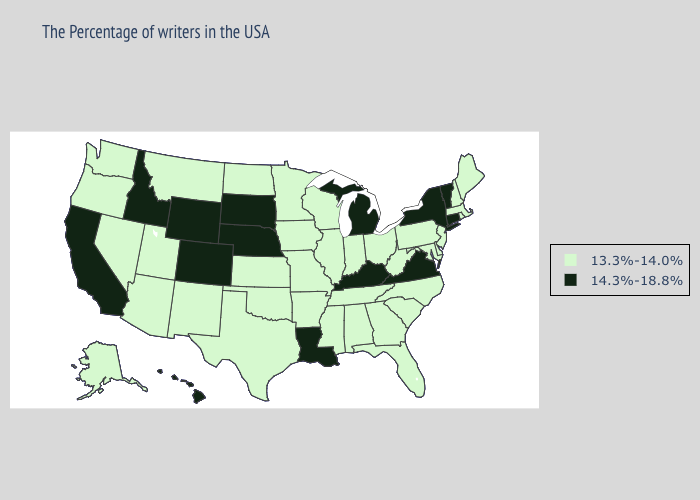Among the states that border Texas , which have the lowest value?
Quick response, please. Arkansas, Oklahoma, New Mexico. Name the states that have a value in the range 14.3%-18.8%?
Concise answer only. Vermont, Connecticut, New York, Virginia, Michigan, Kentucky, Louisiana, Nebraska, South Dakota, Wyoming, Colorado, Idaho, California, Hawaii. Among the states that border Maryland , does Virginia have the lowest value?
Give a very brief answer. No. Does Kentucky have the lowest value in the South?
Be succinct. No. What is the value of Pennsylvania?
Quick response, please. 13.3%-14.0%. Which states hav the highest value in the MidWest?
Write a very short answer. Michigan, Nebraska, South Dakota. Does Georgia have a higher value than West Virginia?
Keep it brief. No. Does the first symbol in the legend represent the smallest category?
Concise answer only. Yes. Name the states that have a value in the range 13.3%-14.0%?
Give a very brief answer. Maine, Massachusetts, Rhode Island, New Hampshire, New Jersey, Delaware, Maryland, Pennsylvania, North Carolina, South Carolina, West Virginia, Ohio, Florida, Georgia, Indiana, Alabama, Tennessee, Wisconsin, Illinois, Mississippi, Missouri, Arkansas, Minnesota, Iowa, Kansas, Oklahoma, Texas, North Dakota, New Mexico, Utah, Montana, Arizona, Nevada, Washington, Oregon, Alaska. Name the states that have a value in the range 14.3%-18.8%?
Short answer required. Vermont, Connecticut, New York, Virginia, Michigan, Kentucky, Louisiana, Nebraska, South Dakota, Wyoming, Colorado, Idaho, California, Hawaii. What is the value of Indiana?
Keep it brief. 13.3%-14.0%. Does the map have missing data?
Give a very brief answer. No. Does the map have missing data?
Concise answer only. No. Does Delaware have the highest value in the USA?
Give a very brief answer. No. What is the value of Delaware?
Be succinct. 13.3%-14.0%. 